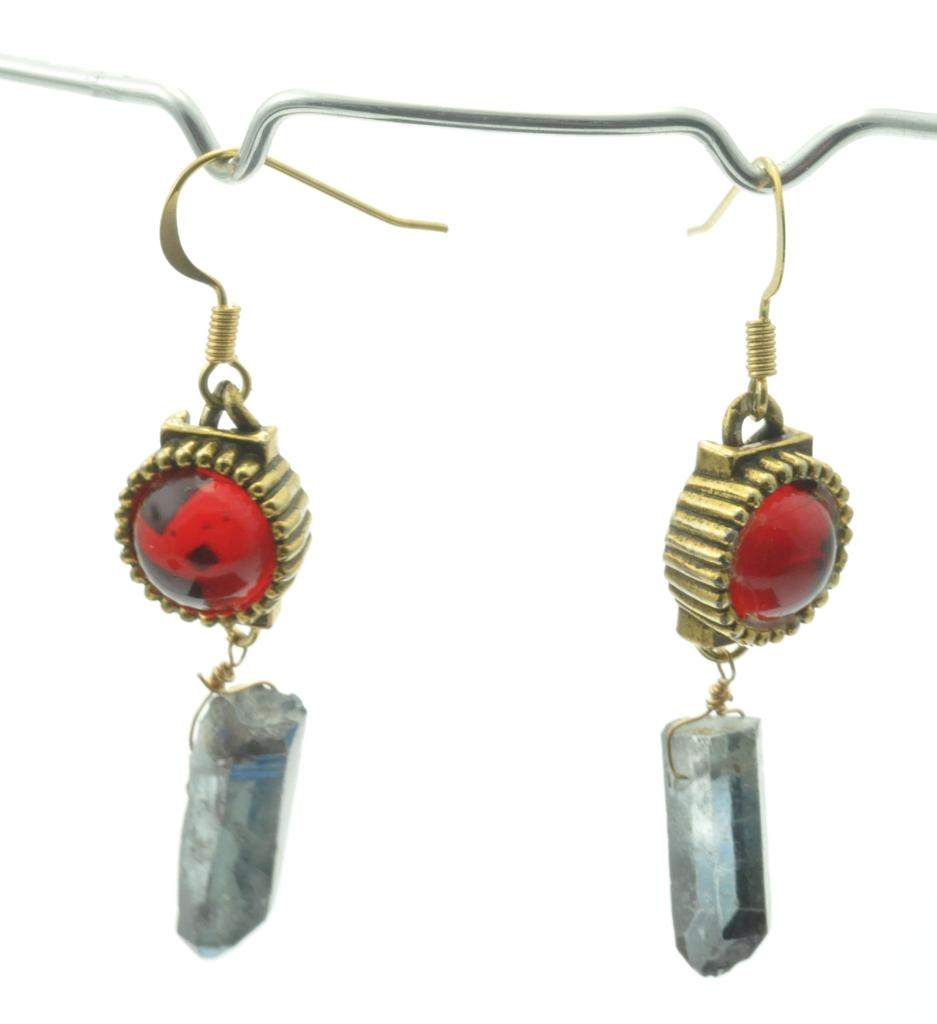What type of jewelry is visible in the image? There are two earrings in the image. Where are the earrings located? The earrings are on a hanger. What is the coast like in the image? There is no coast present in the image; it features two earrings on a hanger. How does the mind of the earrings appear in the image? Earrings do not have minds, so this question cannot be answered. 